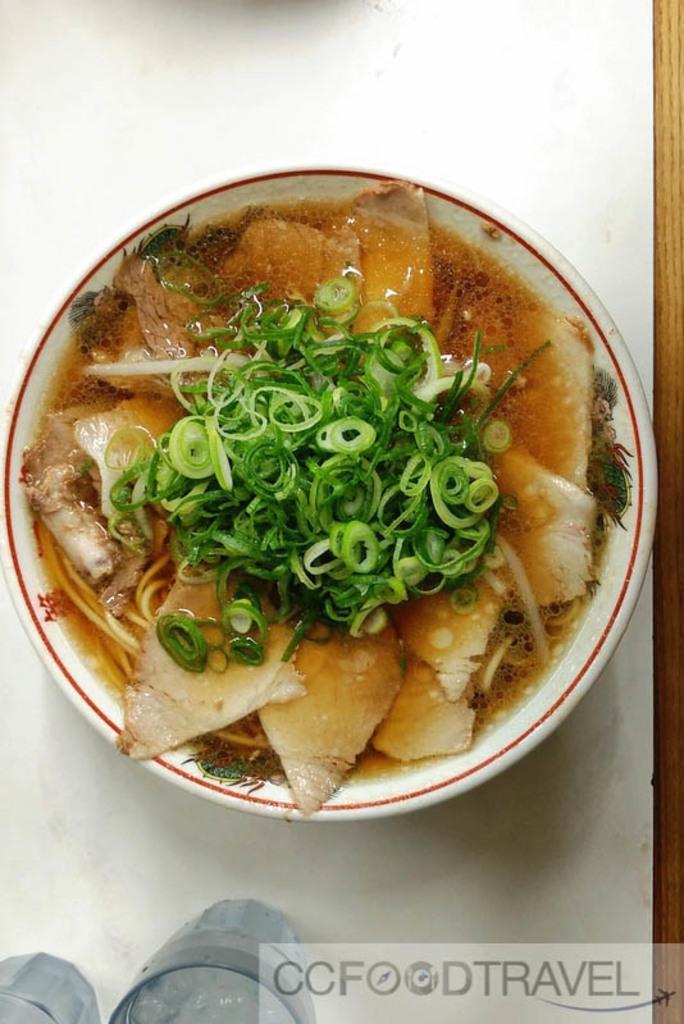Could you give a brief overview of what you see in this image? In this picture we can see some food in a bowl. This bowl is on a white surface. We can see glasses and some text in the bottom right. 